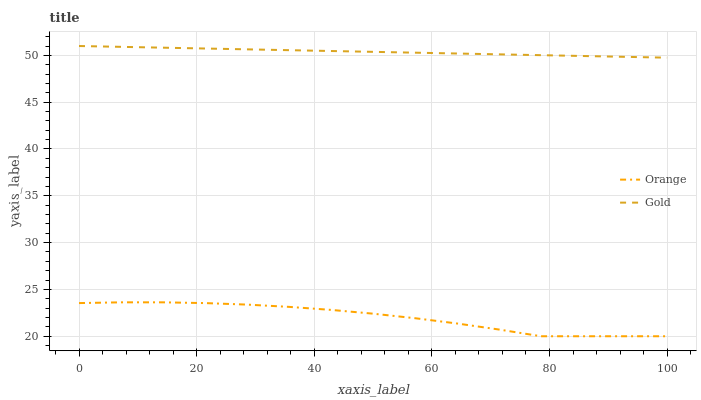Does Orange have the minimum area under the curve?
Answer yes or no. Yes. Does Gold have the maximum area under the curve?
Answer yes or no. Yes. Does Gold have the minimum area under the curve?
Answer yes or no. No. Is Gold the smoothest?
Answer yes or no. Yes. Is Orange the roughest?
Answer yes or no. Yes. Is Gold the roughest?
Answer yes or no. No. Does Orange have the lowest value?
Answer yes or no. Yes. Does Gold have the lowest value?
Answer yes or no. No. Does Gold have the highest value?
Answer yes or no. Yes. Is Orange less than Gold?
Answer yes or no. Yes. Is Gold greater than Orange?
Answer yes or no. Yes. Does Orange intersect Gold?
Answer yes or no. No. 